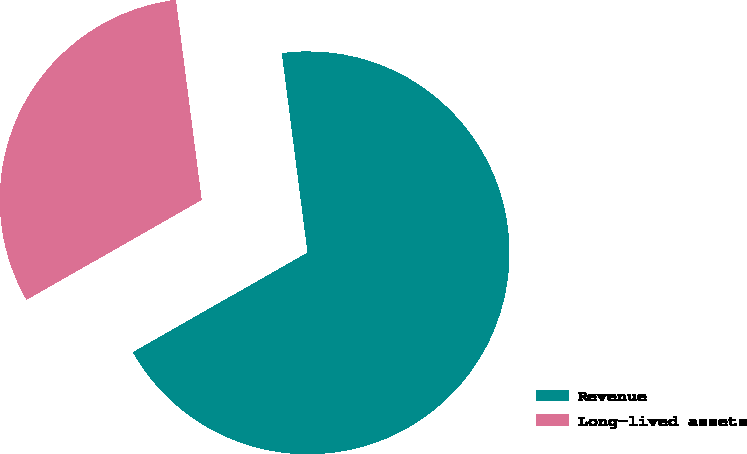Convert chart to OTSL. <chart><loc_0><loc_0><loc_500><loc_500><pie_chart><fcel>Revenue<fcel>Long-lived assets<nl><fcel>68.79%<fcel>31.21%<nl></chart> 